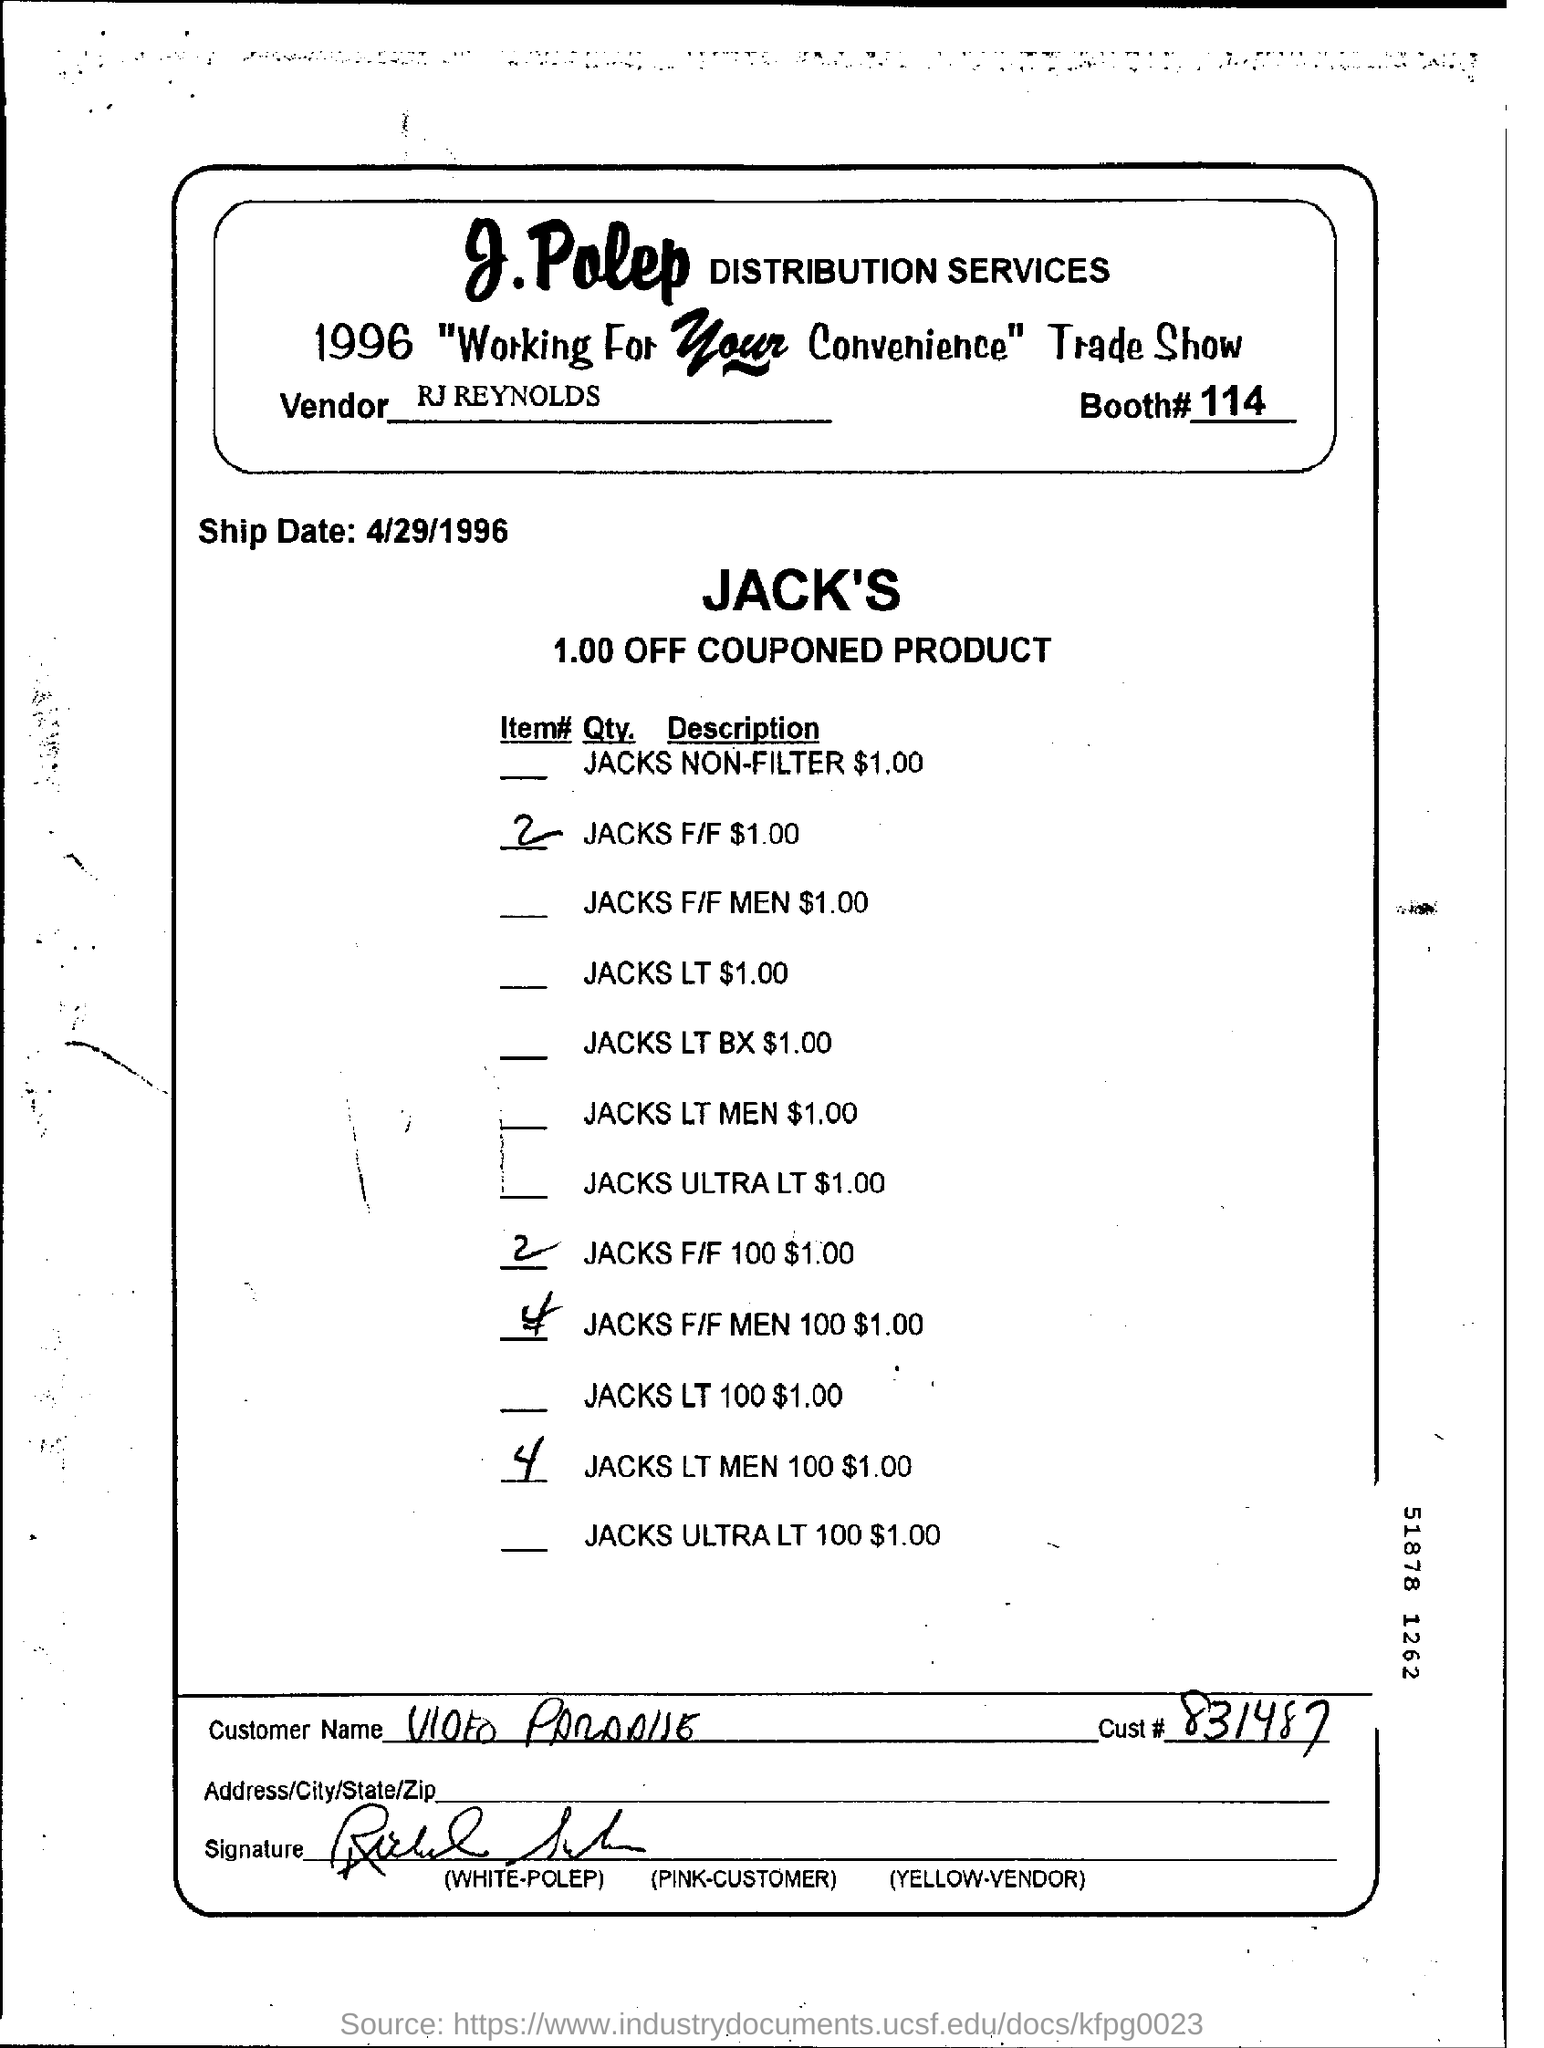Who is the Vendor mentioned in the document?
Ensure brevity in your answer.  RJ REYNOLDS. What is the Booth# no as per the document?
Your answer should be compact. 114. What is the Ship Date mentioned in this document?
Offer a very short reply. 4/29/1996. 